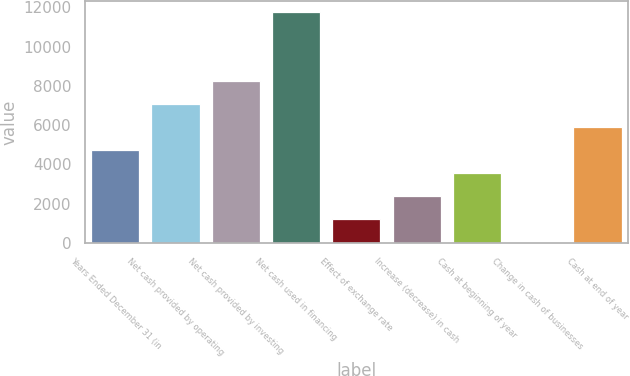Convert chart. <chart><loc_0><loc_0><loc_500><loc_500><bar_chart><fcel>Years Ended December 31 (in<fcel>Net cash provided by operating<fcel>Net cash provided by investing<fcel>Net cash used in financing<fcel>Effect of exchange rate<fcel>Increase (decrease) in cash<fcel>Cash at beginning of year<fcel>Change in cash of businesses<fcel>Cash at end of year<nl><fcel>4717.6<fcel>7064.4<fcel>8237.8<fcel>11758<fcel>1197.4<fcel>2370.8<fcel>3544.2<fcel>24<fcel>5891<nl></chart> 